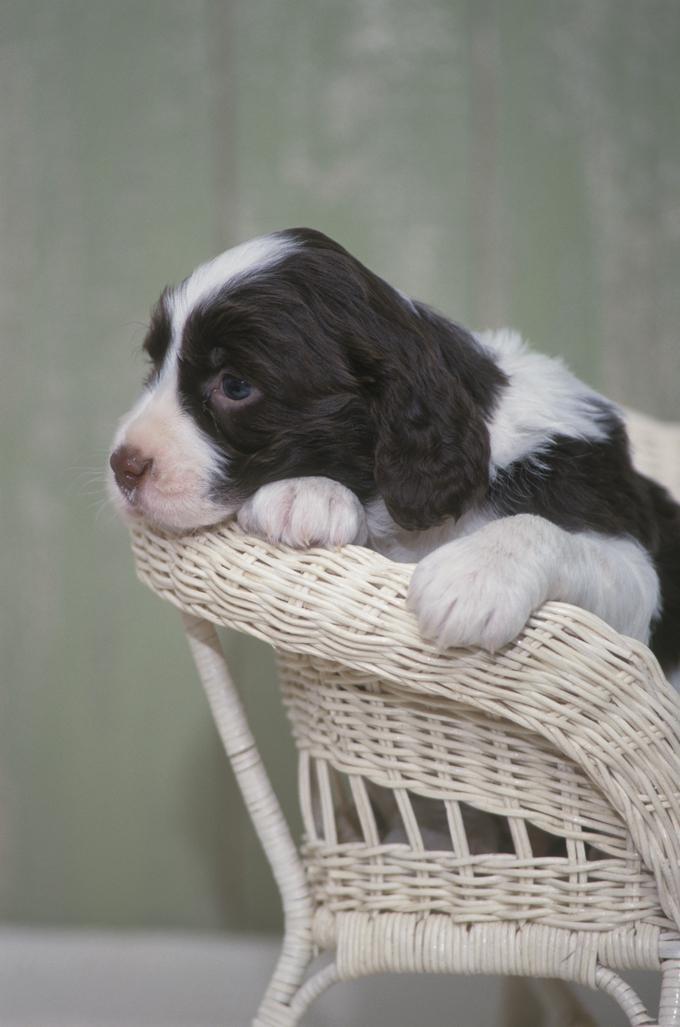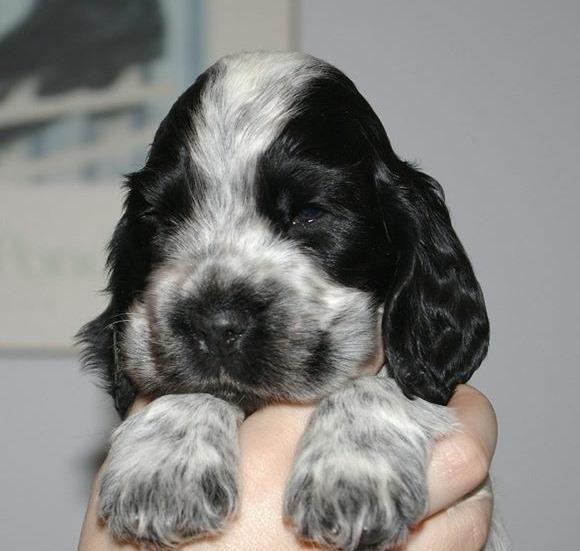The first image is the image on the left, the second image is the image on the right. Examine the images to the left and right. Is the description "An image contains a human holding a dog." accurate? Answer yes or no. Yes. 